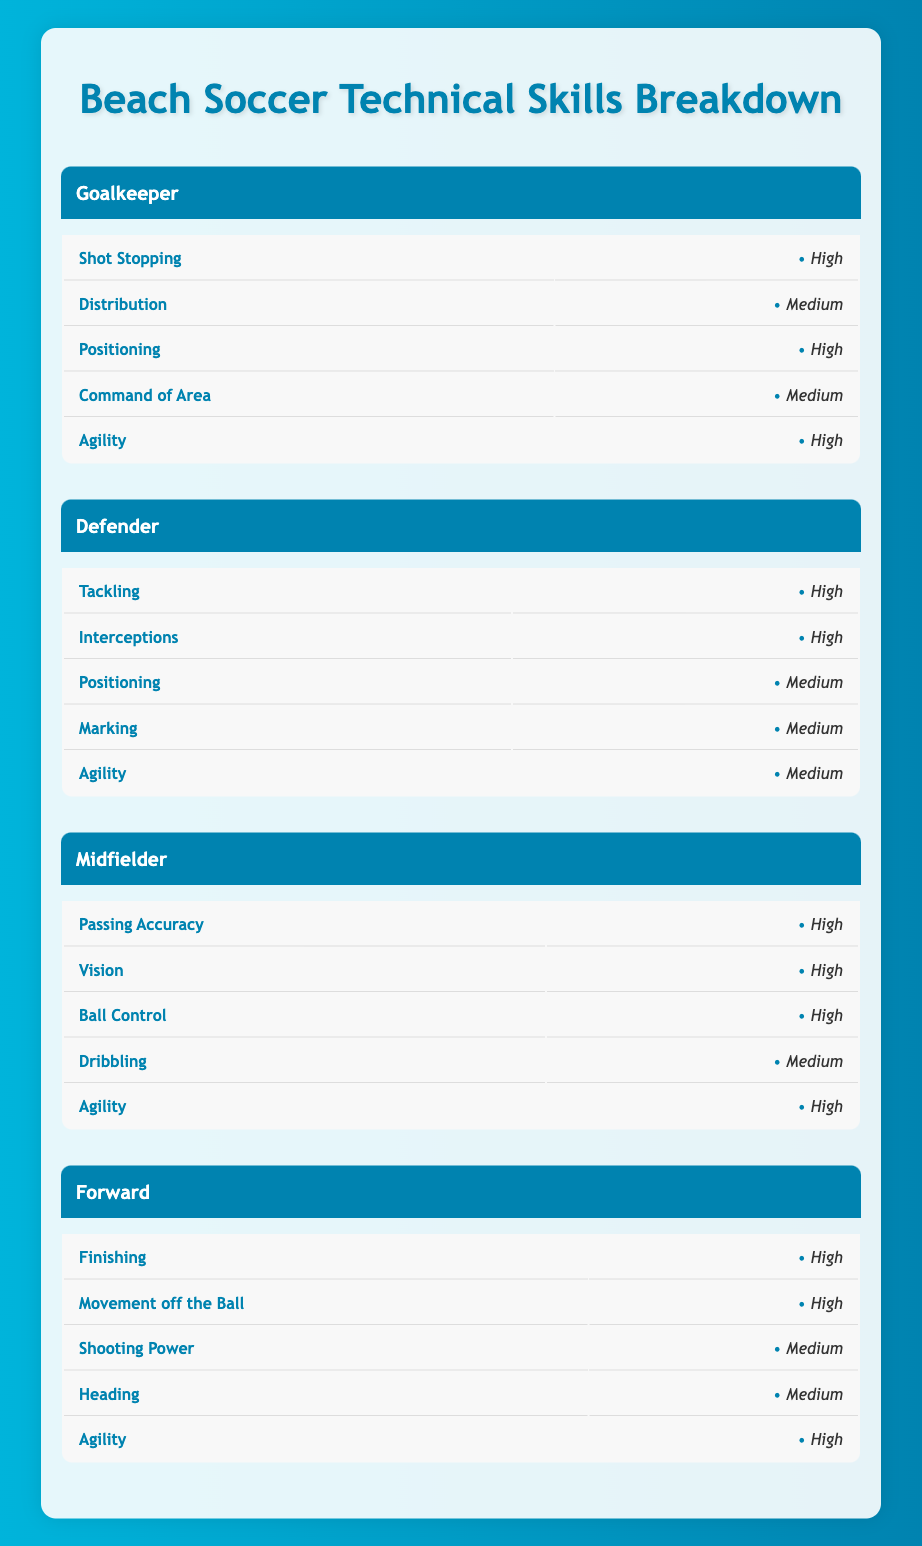What are the technical skills for the Goalkeeper position? To find the technical skills for the Goalkeeper position, look at the section labeled "Goalkeeper" in the table. The skills listed are Shot Stopping, Distribution, Positioning, Command of Area, and Agility, with their corresponding levels of High, Medium, High, Medium, and High.
Answer: Shot Stopping, Distribution, Positioning, Command of Area, Agility Which position has the highest level of Agility? Agility is listed as "High" for all positions: Goalkeeper, Midfielder, Forward, and "Medium" for Defender. Since multiple positions have the same highest level, it can be said that Goalkeeper, Midfielder, and Forward all share this highest level.
Answer: Goalkeeper, Midfielder, Forward What is the average skill level for Defensive positions? The defensive positions are Goalkeeper and Defender. For Goalkeeper, the skills are evaluated as High, Medium, High, Medium, and High, translating to 4 High and 1 Medium. For Defender, the evaluations are High, High, Medium, Medium, and Medium, translating to 2 High and 3 Medium. To assess, we can also consider the factors: assign a value with High as 2, Medium as 1, and Low as 0. For Goalkeeper: (4*2 + 1*1) = 9 out of 10. For Defender: (2*2 + 3*1) = 7 out of 10. Hence, the average skilla for both positions is (9 + 7) / 2 = 8.
Answer: 8 Is "Vision" a skill listed for Midfielders? The table can be referenced directly to the Midfielder section, where "Vision" is indeed listed as one of the skills with a High level. Therefore, the statement is true.
Answer: Yes Which position requires the most emphasis on Tackling? The position that requires the most emphasis on Tackling would be the Defender, as Tackling is marked as High for this role. Other positions either do not have Tackling listed or lack it as a primary skill. Therefore, it emphasizes that Tackling is crucial for Defenders compared to others.
Answer: Defender 